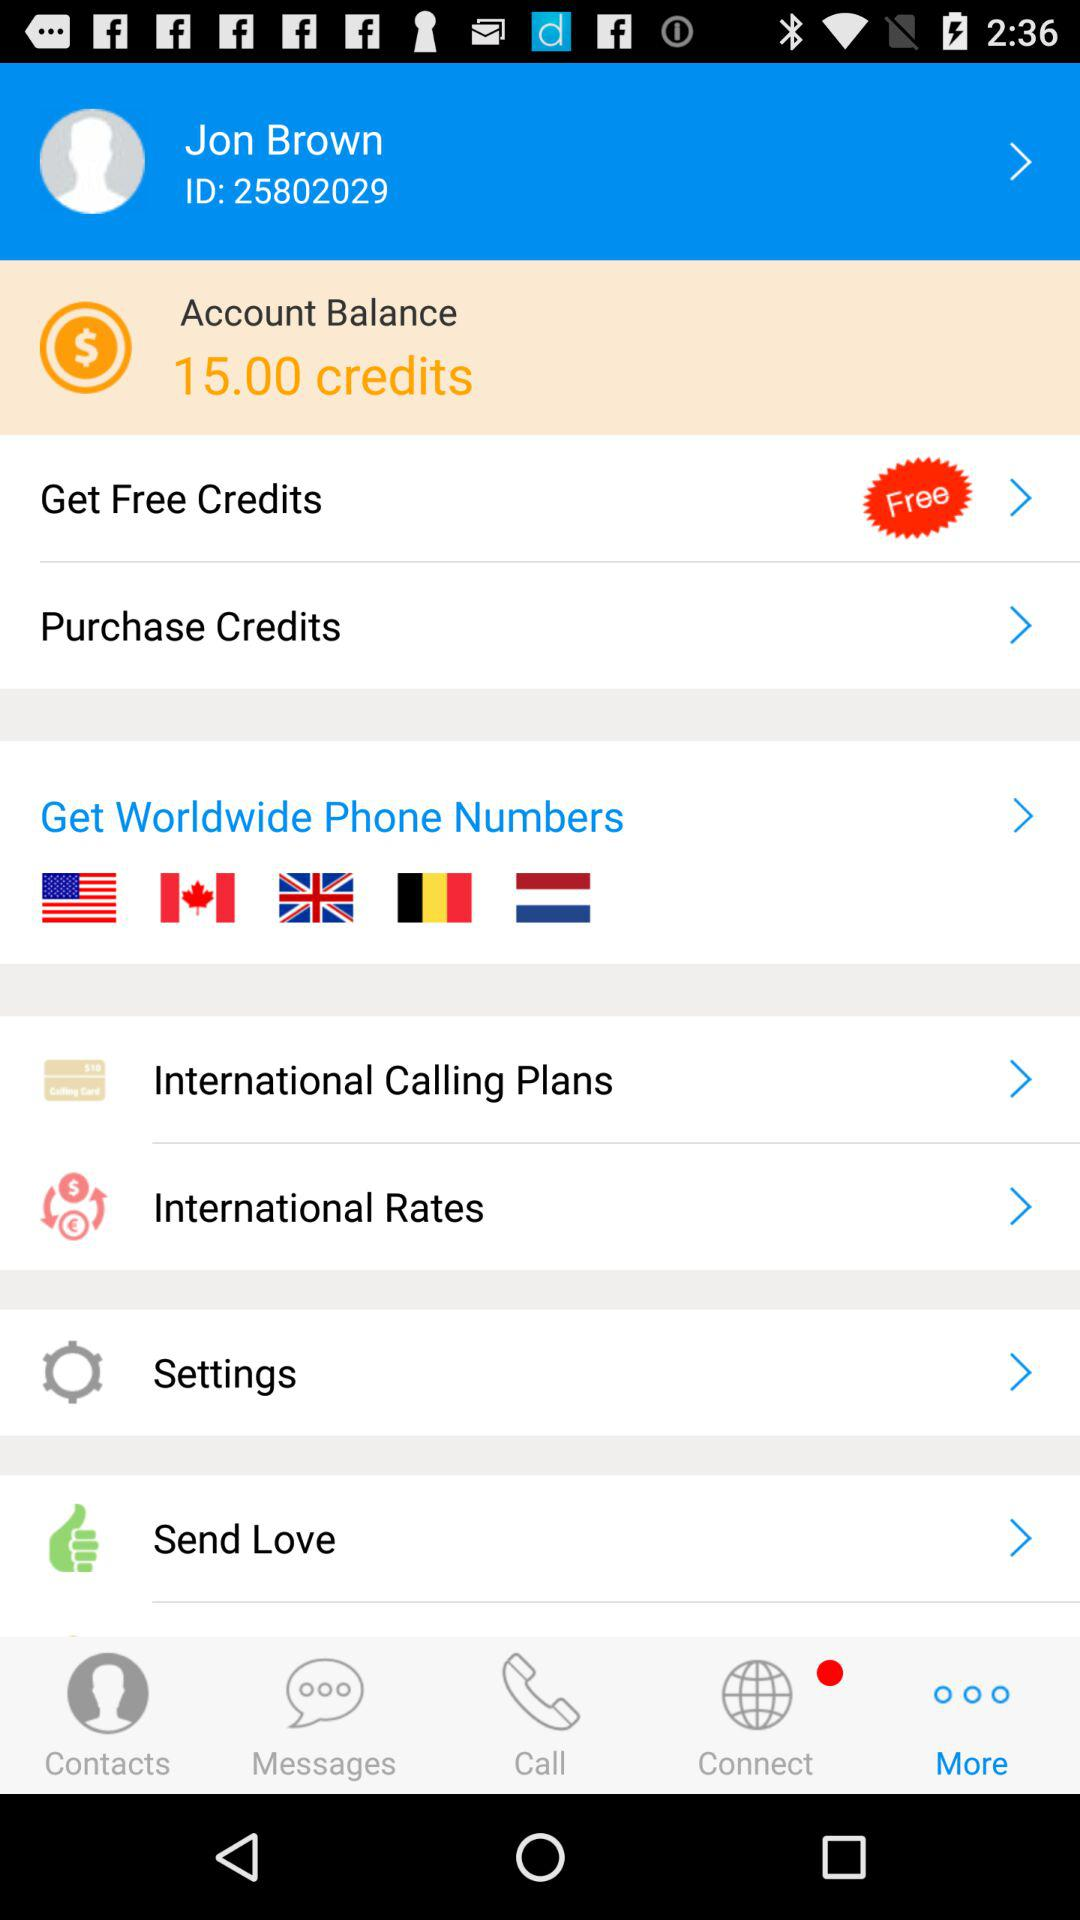What is the identity document number? The identity document number is 25802029. 